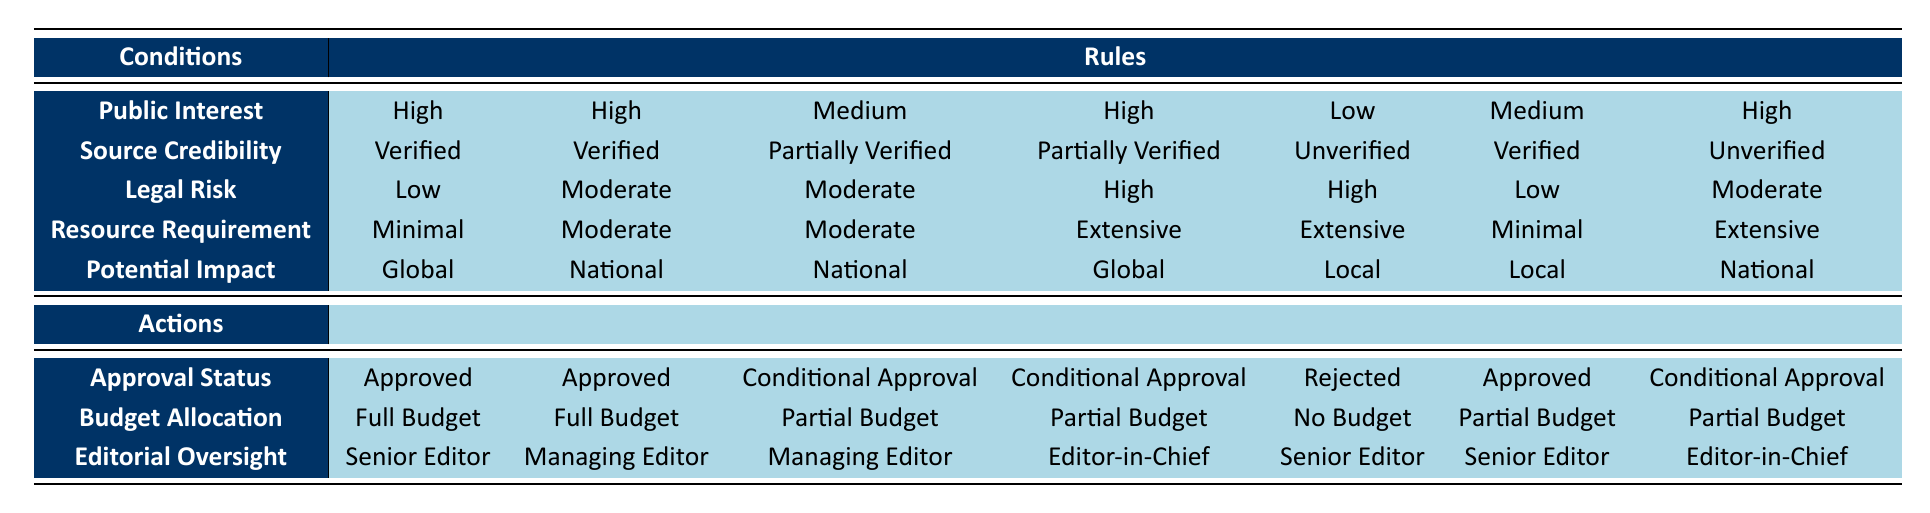What is the approval status for stories with High Public Interest and Verified Source Credibility? In the table, we start by checking the row for "High" under Public Interest and "Verified" under Source Credibility. There are two instances that match these conditions. They both indicate an "Approved" status.
Answer: Approved Is there a story with Low Legal Risk that is Approved? We look for "Low" under Legal Risk and check the corresponding Approval Status. There is one instance with "Low" Legal Risk, which is related to "Medium" Public Interest, "Verified" Source Credibility, "Minimal" Resource Requirement, and "Local" Potential Impact. This story has an "Approved" status.
Answer: Yes What is the Budget Allocation for a story with Medium Public Interest and Partially Verified Source Credibility? We find the row corresponding to "Medium" Public Interest and "Partially Verified" Source Credibility. Both columns show a "Conditional Approval", which relates to a "Partial Budget" allocation.
Answer: Partial Budget How many stories are conditionally approved when the Legal Risk is High? We identify the rows that mention "High" for Legal Risk. There are three rows with "High" legal risk: one is conditionally approved, while the others are rejected or approved. Therefore, only one story receives conditional approval under high legal risk.
Answer: 1 Is a story with Extensive Resource Requirement and Unverified Source Credibility ever approved? We look for "Extensive" under Resource Requirement and "Unverified" under Source Credibility. There are two instances, but both result in rejection or conditional approval, specifically for "Local" and "National" situations. Hence, there is no approved story under these conditions.
Answer: No For which criteria does a story get journalistic approval with a Global potential impact? We analyze the rows that correspond to "Global" under Potential Impact. There are two stories associated with "High" Public Interest and "Verified" Source Credibility that receive approval. Thus, the criteria leading to approval with Global impact would follow these conditions: High Public Interest, Verified Source Credibility, Low or Moderate Legal Risk, and Minimal or Moderate Resource Requirement.
Answer: High Public Interest and Verified Source Credibility How many stories receive "Partial Budget" when the Potential Impact is Local? We review the rows with "Local" Potential Impact. There are three stories that correspond to "Partial Budget" allocation. Therefore, the count of stories receiving a partial budget with Local potential impact is three.
Answer: 3 If a story has Moderate Resource Requirement and is Conditionally Approved, what is the maximum Legal Risk it can have? We locate the instances where "Moderate" Resource Requirements correspond to "Conditional Approval". There are two instances with Moderate Legal Risk, but not High; hence the maximum legal risk possible while still achieving Conditional Approval under these circumstances is moderate.
Answer: Moderate What is required for a story with High Public Interest, High Legal Risk, and Minimal Resource Requirement to receive approval? Analyzing the conditions of High Public Interest and High Legal Risk, we find one story. However, it is only conditionally approved and allocated a Partial Budget rather than an outright approval. Thus, another condition (like having Verified Source Credibility) would be needed for approval in this case.
Answer: Verified Source Credibility 